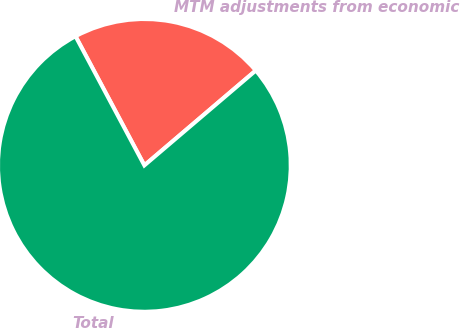Convert chart. <chart><loc_0><loc_0><loc_500><loc_500><pie_chart><fcel>MTM adjustments from economic<fcel>Total<nl><fcel>21.57%<fcel>78.43%<nl></chart> 